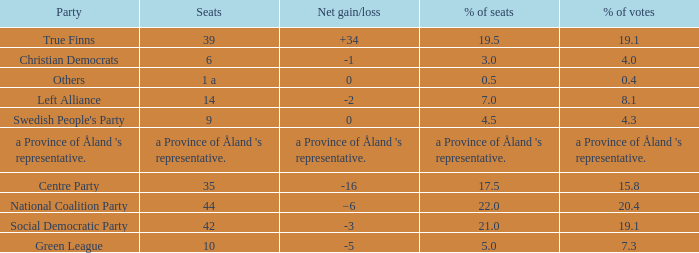When the Swedish People's Party had a net gain/loss of 0, how many seats did they have? 9.0. 